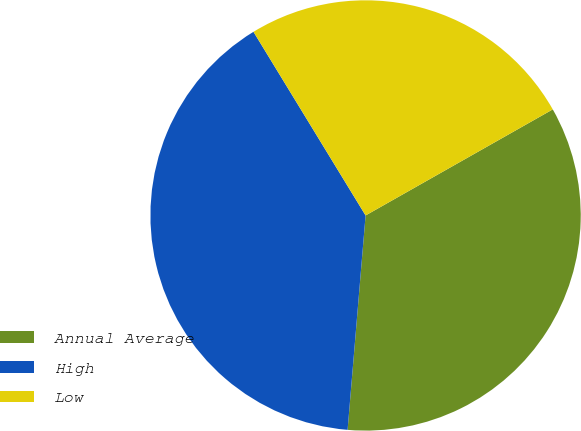Convert chart to OTSL. <chart><loc_0><loc_0><loc_500><loc_500><pie_chart><fcel>Annual Average<fcel>High<fcel>Low<nl><fcel>34.54%<fcel>39.95%<fcel>25.52%<nl></chart> 